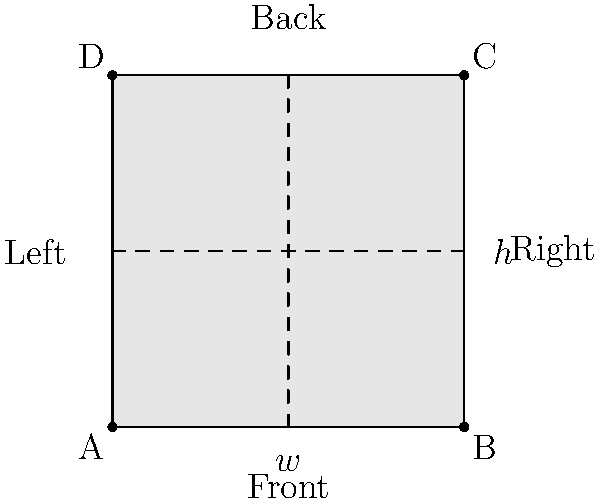As a fashion-forward meditation enthusiast, you're designing a stylish meditation cushion. The cushion is square-shaped with width $w$ and height $h$. If the optimal pressure distribution is achieved when the ratio of width to height (w:h) is 2:1, and the cushion volume for comfort should be 10,000 cm³, what are the dimensions (w and h) of the cushion? Let's approach this step-by-step:

1) We know that the ratio of width to height is 2:1, so we can express width in terms of height:
   $w = 2h$

2) The volume of the cushion is given by the formula:
   $V = w \times w \times h$ (since it's a square cushion)

3) Substituting $w = 2h$ into the volume formula:
   $V = (2h) \times (2h) \times h = 4h^3$

4) We're told the volume should be 10,000 cm³:
   $4h^3 = 10,000$

5) Solving for h:
   $h^3 = 2,500$
   $h = \sqrt[3]{2,500} \approx 13.57$ cm

6) Now we can calculate w:
   $w = 2h \approx 2 \times 13.57 = 27.14$ cm

7) Rounding to the nearest centimeter for practical purposes:
   $h = 14$ cm
   $w = 28$ cm
Answer: Width: 28 cm, Height: 14 cm 